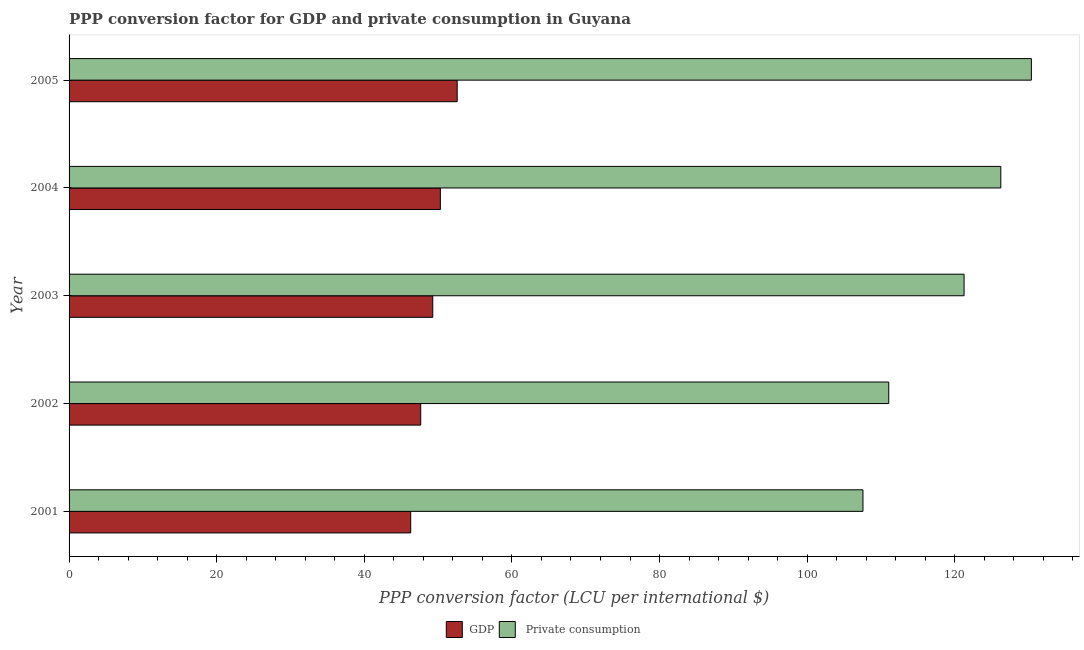How many different coloured bars are there?
Offer a very short reply. 2. How many groups of bars are there?
Your response must be concise. 5. Are the number of bars per tick equal to the number of legend labels?
Ensure brevity in your answer.  Yes. How many bars are there on the 2nd tick from the top?
Offer a terse response. 2. In how many cases, is the number of bars for a given year not equal to the number of legend labels?
Your answer should be compact. 0. What is the ppp conversion factor for private consumption in 2003?
Offer a very short reply. 121.26. Across all years, what is the maximum ppp conversion factor for private consumption?
Your response must be concise. 130.38. Across all years, what is the minimum ppp conversion factor for gdp?
Keep it short and to the point. 46.29. In which year was the ppp conversion factor for private consumption maximum?
Your response must be concise. 2005. In which year was the ppp conversion factor for private consumption minimum?
Offer a terse response. 2001. What is the total ppp conversion factor for gdp in the graph?
Offer a terse response. 246.09. What is the difference between the ppp conversion factor for private consumption in 2004 and that in 2005?
Your answer should be very brief. -4.14. What is the difference between the ppp conversion factor for private consumption in 2004 and the ppp conversion factor for gdp in 2005?
Provide a succinct answer. 73.65. What is the average ppp conversion factor for private consumption per year?
Ensure brevity in your answer.  119.3. In the year 2003, what is the difference between the ppp conversion factor for private consumption and ppp conversion factor for gdp?
Your answer should be compact. 71.98. Is the difference between the ppp conversion factor for gdp in 2003 and 2004 greater than the difference between the ppp conversion factor for private consumption in 2003 and 2004?
Give a very brief answer. Yes. What is the difference between the highest and the second highest ppp conversion factor for private consumption?
Give a very brief answer. 4.14. What is the difference between the highest and the lowest ppp conversion factor for gdp?
Keep it short and to the point. 6.3. In how many years, is the ppp conversion factor for private consumption greater than the average ppp conversion factor for private consumption taken over all years?
Keep it short and to the point. 3. Is the sum of the ppp conversion factor for gdp in 2001 and 2003 greater than the maximum ppp conversion factor for private consumption across all years?
Keep it short and to the point. No. What does the 1st bar from the top in 2003 represents?
Your answer should be compact.  Private consumption. What does the 2nd bar from the bottom in 2002 represents?
Offer a terse response.  Private consumption. How many bars are there?
Your answer should be very brief. 10. How many years are there in the graph?
Your answer should be compact. 5. Where does the legend appear in the graph?
Your answer should be very brief. Bottom center. How are the legend labels stacked?
Ensure brevity in your answer.  Horizontal. What is the title of the graph?
Give a very brief answer. PPP conversion factor for GDP and private consumption in Guyana. What is the label or title of the X-axis?
Give a very brief answer. PPP conversion factor (LCU per international $). What is the PPP conversion factor (LCU per international $) in GDP in 2001?
Make the answer very short. 46.29. What is the PPP conversion factor (LCU per international $) of  Private consumption in 2001?
Ensure brevity in your answer.  107.56. What is the PPP conversion factor (LCU per international $) in GDP in 2002?
Offer a terse response. 47.64. What is the PPP conversion factor (LCU per international $) of  Private consumption in 2002?
Keep it short and to the point. 111.05. What is the PPP conversion factor (LCU per international $) in GDP in 2003?
Provide a succinct answer. 49.27. What is the PPP conversion factor (LCU per international $) in  Private consumption in 2003?
Offer a terse response. 121.26. What is the PPP conversion factor (LCU per international $) in GDP in 2004?
Offer a terse response. 50.3. What is the PPP conversion factor (LCU per international $) in  Private consumption in 2004?
Keep it short and to the point. 126.24. What is the PPP conversion factor (LCU per international $) in GDP in 2005?
Provide a short and direct response. 52.58. What is the PPP conversion factor (LCU per international $) in  Private consumption in 2005?
Offer a very short reply. 130.38. Across all years, what is the maximum PPP conversion factor (LCU per international $) of GDP?
Provide a succinct answer. 52.58. Across all years, what is the maximum PPP conversion factor (LCU per international $) of  Private consumption?
Your answer should be compact. 130.38. Across all years, what is the minimum PPP conversion factor (LCU per international $) in GDP?
Offer a very short reply. 46.29. Across all years, what is the minimum PPP conversion factor (LCU per international $) of  Private consumption?
Your answer should be very brief. 107.56. What is the total PPP conversion factor (LCU per international $) in GDP in the graph?
Offer a terse response. 246.09. What is the total PPP conversion factor (LCU per international $) of  Private consumption in the graph?
Ensure brevity in your answer.  596.49. What is the difference between the PPP conversion factor (LCU per international $) in GDP in 2001 and that in 2002?
Keep it short and to the point. -1.36. What is the difference between the PPP conversion factor (LCU per international $) of  Private consumption in 2001 and that in 2002?
Make the answer very short. -3.49. What is the difference between the PPP conversion factor (LCU per international $) of GDP in 2001 and that in 2003?
Make the answer very short. -2.99. What is the difference between the PPP conversion factor (LCU per international $) of  Private consumption in 2001 and that in 2003?
Make the answer very short. -13.7. What is the difference between the PPP conversion factor (LCU per international $) in GDP in 2001 and that in 2004?
Your answer should be compact. -4.02. What is the difference between the PPP conversion factor (LCU per international $) in  Private consumption in 2001 and that in 2004?
Your answer should be compact. -18.68. What is the difference between the PPP conversion factor (LCU per international $) of GDP in 2001 and that in 2005?
Your answer should be very brief. -6.3. What is the difference between the PPP conversion factor (LCU per international $) in  Private consumption in 2001 and that in 2005?
Offer a terse response. -22.82. What is the difference between the PPP conversion factor (LCU per international $) of GDP in 2002 and that in 2003?
Give a very brief answer. -1.63. What is the difference between the PPP conversion factor (LCU per international $) in  Private consumption in 2002 and that in 2003?
Offer a terse response. -10.21. What is the difference between the PPP conversion factor (LCU per international $) of GDP in 2002 and that in 2004?
Ensure brevity in your answer.  -2.66. What is the difference between the PPP conversion factor (LCU per international $) in  Private consumption in 2002 and that in 2004?
Your response must be concise. -15.18. What is the difference between the PPP conversion factor (LCU per international $) in GDP in 2002 and that in 2005?
Provide a short and direct response. -4.94. What is the difference between the PPP conversion factor (LCU per international $) in  Private consumption in 2002 and that in 2005?
Your answer should be very brief. -19.32. What is the difference between the PPP conversion factor (LCU per international $) of GDP in 2003 and that in 2004?
Provide a short and direct response. -1.03. What is the difference between the PPP conversion factor (LCU per international $) of  Private consumption in 2003 and that in 2004?
Offer a terse response. -4.98. What is the difference between the PPP conversion factor (LCU per international $) of GDP in 2003 and that in 2005?
Offer a terse response. -3.31. What is the difference between the PPP conversion factor (LCU per international $) of  Private consumption in 2003 and that in 2005?
Your response must be concise. -9.12. What is the difference between the PPP conversion factor (LCU per international $) of GDP in 2004 and that in 2005?
Your answer should be very brief. -2.28. What is the difference between the PPP conversion factor (LCU per international $) of  Private consumption in 2004 and that in 2005?
Give a very brief answer. -4.14. What is the difference between the PPP conversion factor (LCU per international $) in GDP in 2001 and the PPP conversion factor (LCU per international $) in  Private consumption in 2002?
Offer a very short reply. -64.77. What is the difference between the PPP conversion factor (LCU per international $) in GDP in 2001 and the PPP conversion factor (LCU per international $) in  Private consumption in 2003?
Your response must be concise. -74.97. What is the difference between the PPP conversion factor (LCU per international $) in GDP in 2001 and the PPP conversion factor (LCU per international $) in  Private consumption in 2004?
Give a very brief answer. -79.95. What is the difference between the PPP conversion factor (LCU per international $) in GDP in 2001 and the PPP conversion factor (LCU per international $) in  Private consumption in 2005?
Make the answer very short. -84.09. What is the difference between the PPP conversion factor (LCU per international $) of GDP in 2002 and the PPP conversion factor (LCU per international $) of  Private consumption in 2003?
Give a very brief answer. -73.62. What is the difference between the PPP conversion factor (LCU per international $) of GDP in 2002 and the PPP conversion factor (LCU per international $) of  Private consumption in 2004?
Your response must be concise. -78.59. What is the difference between the PPP conversion factor (LCU per international $) of GDP in 2002 and the PPP conversion factor (LCU per international $) of  Private consumption in 2005?
Make the answer very short. -82.73. What is the difference between the PPP conversion factor (LCU per international $) in GDP in 2003 and the PPP conversion factor (LCU per international $) in  Private consumption in 2004?
Offer a terse response. -76.96. What is the difference between the PPP conversion factor (LCU per international $) in GDP in 2003 and the PPP conversion factor (LCU per international $) in  Private consumption in 2005?
Offer a terse response. -81.1. What is the difference between the PPP conversion factor (LCU per international $) in GDP in 2004 and the PPP conversion factor (LCU per international $) in  Private consumption in 2005?
Provide a succinct answer. -80.07. What is the average PPP conversion factor (LCU per international $) of GDP per year?
Give a very brief answer. 49.22. What is the average PPP conversion factor (LCU per international $) of  Private consumption per year?
Keep it short and to the point. 119.3. In the year 2001, what is the difference between the PPP conversion factor (LCU per international $) of GDP and PPP conversion factor (LCU per international $) of  Private consumption?
Give a very brief answer. -61.27. In the year 2002, what is the difference between the PPP conversion factor (LCU per international $) of GDP and PPP conversion factor (LCU per international $) of  Private consumption?
Provide a short and direct response. -63.41. In the year 2003, what is the difference between the PPP conversion factor (LCU per international $) in GDP and PPP conversion factor (LCU per international $) in  Private consumption?
Make the answer very short. -71.98. In the year 2004, what is the difference between the PPP conversion factor (LCU per international $) in GDP and PPP conversion factor (LCU per international $) in  Private consumption?
Provide a succinct answer. -75.93. In the year 2005, what is the difference between the PPP conversion factor (LCU per international $) of GDP and PPP conversion factor (LCU per international $) of  Private consumption?
Give a very brief answer. -77.79. What is the ratio of the PPP conversion factor (LCU per international $) in GDP in 2001 to that in 2002?
Your answer should be compact. 0.97. What is the ratio of the PPP conversion factor (LCU per international $) of  Private consumption in 2001 to that in 2002?
Provide a succinct answer. 0.97. What is the ratio of the PPP conversion factor (LCU per international $) in GDP in 2001 to that in 2003?
Keep it short and to the point. 0.94. What is the ratio of the PPP conversion factor (LCU per international $) in  Private consumption in 2001 to that in 2003?
Offer a terse response. 0.89. What is the ratio of the PPP conversion factor (LCU per international $) in GDP in 2001 to that in 2004?
Provide a short and direct response. 0.92. What is the ratio of the PPP conversion factor (LCU per international $) of  Private consumption in 2001 to that in 2004?
Ensure brevity in your answer.  0.85. What is the ratio of the PPP conversion factor (LCU per international $) in GDP in 2001 to that in 2005?
Provide a succinct answer. 0.88. What is the ratio of the PPP conversion factor (LCU per international $) in  Private consumption in 2001 to that in 2005?
Give a very brief answer. 0.82. What is the ratio of the PPP conversion factor (LCU per international $) of GDP in 2002 to that in 2003?
Make the answer very short. 0.97. What is the ratio of the PPP conversion factor (LCU per international $) in  Private consumption in 2002 to that in 2003?
Keep it short and to the point. 0.92. What is the ratio of the PPP conversion factor (LCU per international $) of GDP in 2002 to that in 2004?
Offer a terse response. 0.95. What is the ratio of the PPP conversion factor (LCU per international $) of  Private consumption in 2002 to that in 2004?
Give a very brief answer. 0.88. What is the ratio of the PPP conversion factor (LCU per international $) in GDP in 2002 to that in 2005?
Offer a very short reply. 0.91. What is the ratio of the PPP conversion factor (LCU per international $) of  Private consumption in 2002 to that in 2005?
Provide a short and direct response. 0.85. What is the ratio of the PPP conversion factor (LCU per international $) in GDP in 2003 to that in 2004?
Offer a terse response. 0.98. What is the ratio of the PPP conversion factor (LCU per international $) of  Private consumption in 2003 to that in 2004?
Provide a succinct answer. 0.96. What is the ratio of the PPP conversion factor (LCU per international $) of GDP in 2003 to that in 2005?
Make the answer very short. 0.94. What is the ratio of the PPP conversion factor (LCU per international $) in  Private consumption in 2003 to that in 2005?
Your answer should be very brief. 0.93. What is the ratio of the PPP conversion factor (LCU per international $) of GDP in 2004 to that in 2005?
Give a very brief answer. 0.96. What is the ratio of the PPP conversion factor (LCU per international $) of  Private consumption in 2004 to that in 2005?
Provide a succinct answer. 0.97. What is the difference between the highest and the second highest PPP conversion factor (LCU per international $) of GDP?
Your answer should be compact. 2.28. What is the difference between the highest and the second highest PPP conversion factor (LCU per international $) in  Private consumption?
Offer a very short reply. 4.14. What is the difference between the highest and the lowest PPP conversion factor (LCU per international $) of GDP?
Your response must be concise. 6.3. What is the difference between the highest and the lowest PPP conversion factor (LCU per international $) in  Private consumption?
Your answer should be very brief. 22.82. 